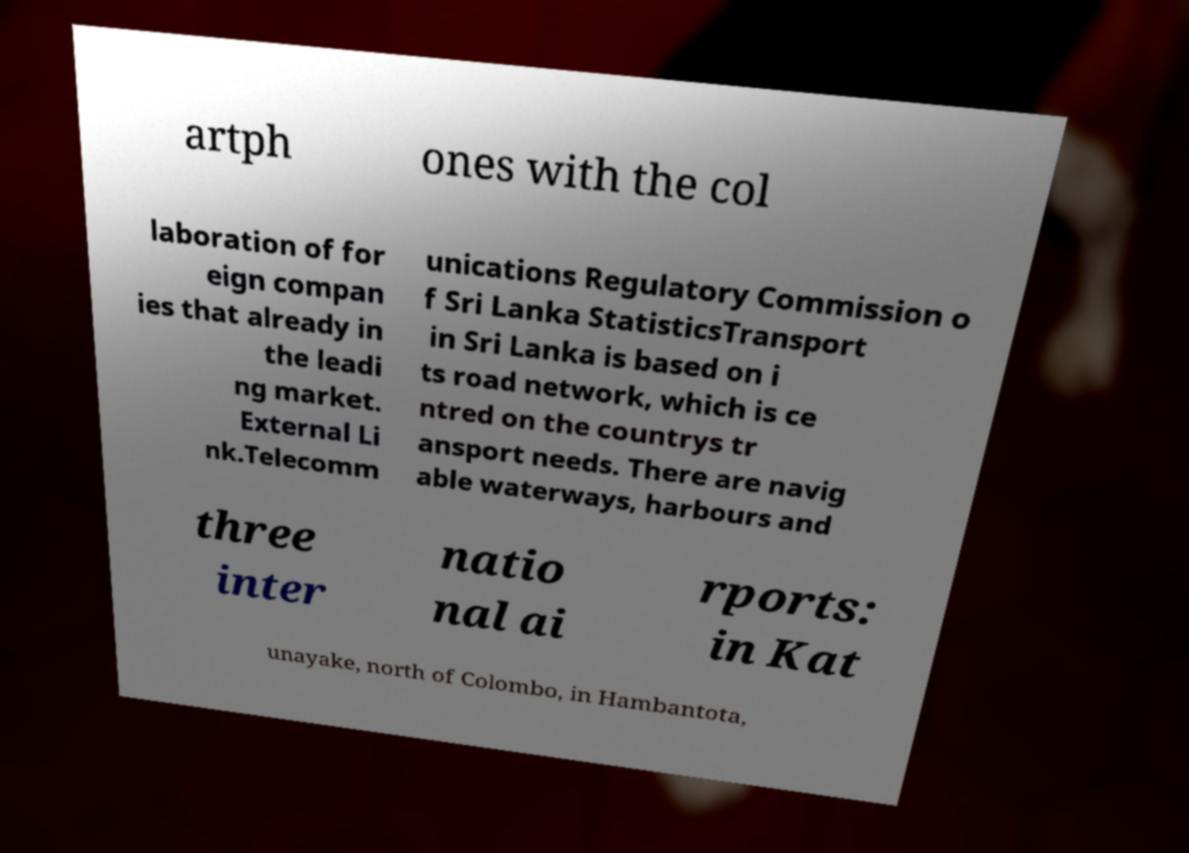Can you accurately transcribe the text from the provided image for me? artph ones with the col laboration of for eign compan ies that already in the leadi ng market. External Li nk.Telecomm unications Regulatory Commission o f Sri Lanka StatisticsTransport in Sri Lanka is based on i ts road network, which is ce ntred on the countrys tr ansport needs. There are navig able waterways, harbours and three inter natio nal ai rports: in Kat unayake, north of Colombo, in Hambantota, 